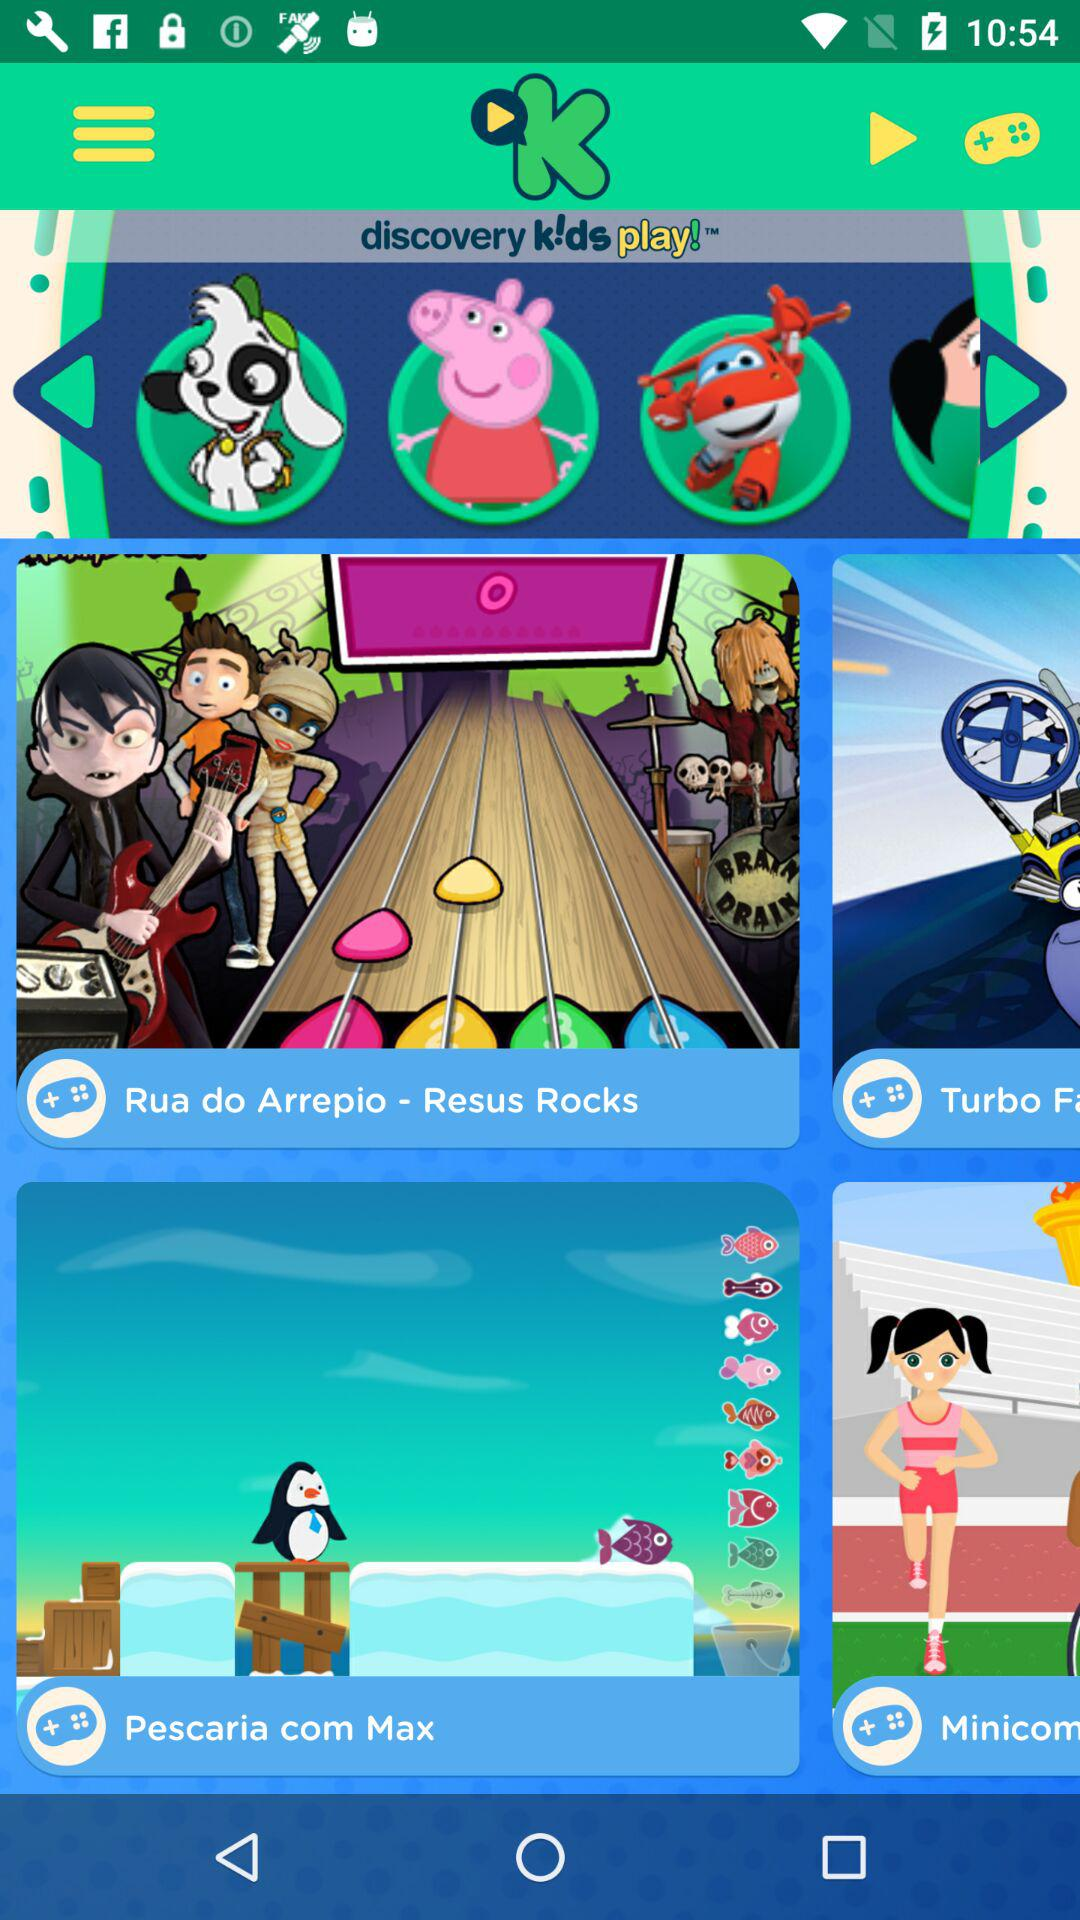Which cartoon character is selected?
When the provided information is insufficient, respond with <no answer>. <no answer> 